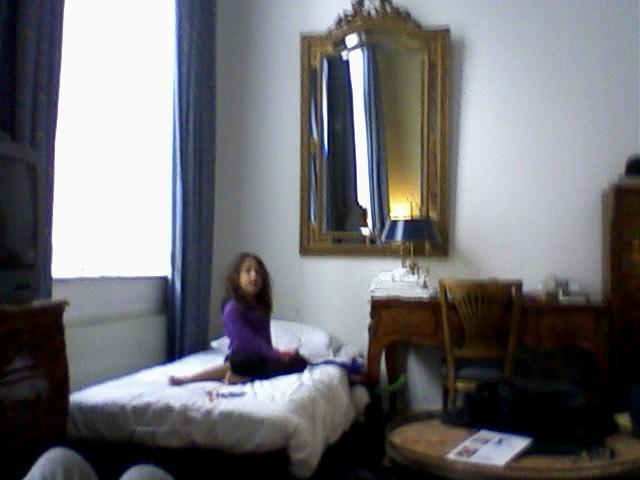Why is the image blurred? Please explain your reasoning. unfocussed. The photo seems to be a bit unfocused. 